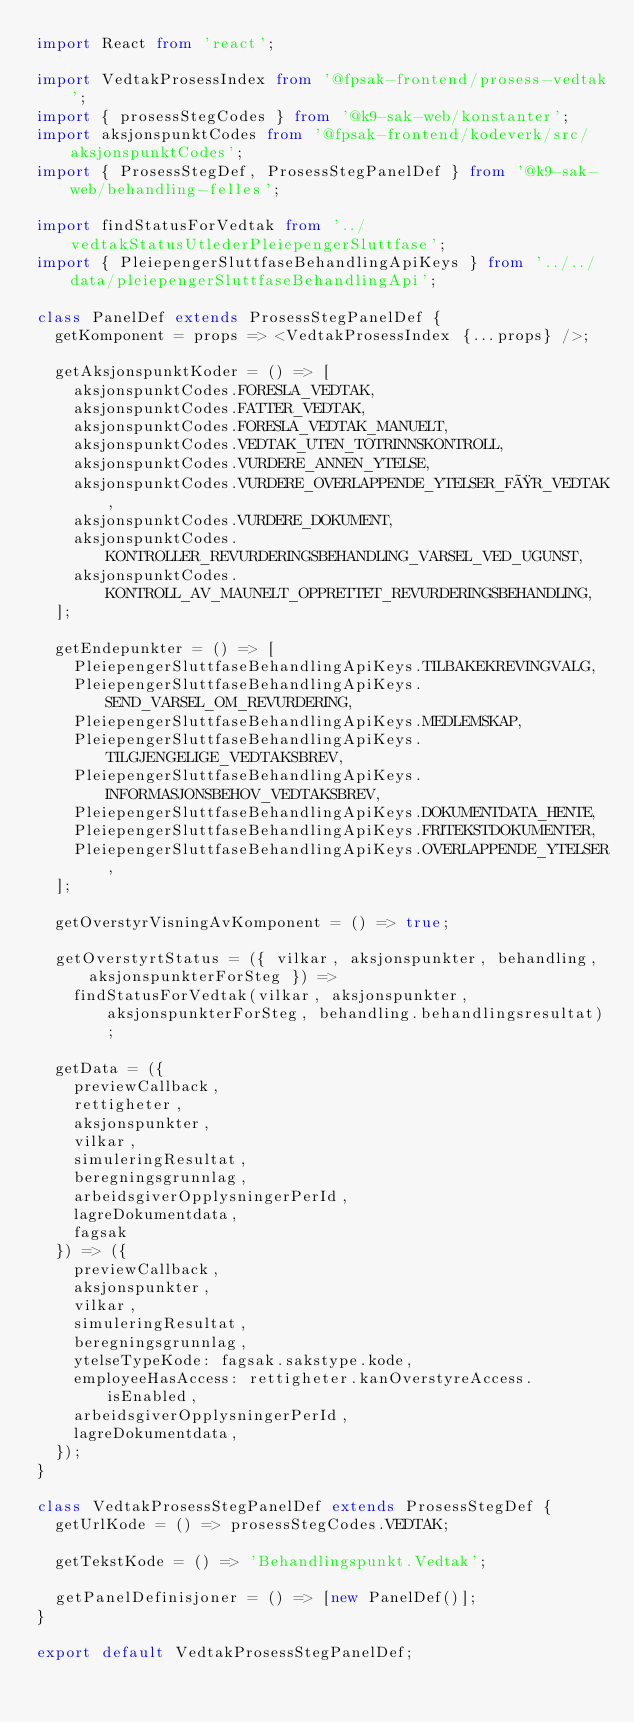<code> <loc_0><loc_0><loc_500><loc_500><_TypeScript_>import React from 'react';

import VedtakProsessIndex from '@fpsak-frontend/prosess-vedtak';
import { prosessStegCodes } from '@k9-sak-web/konstanter';
import aksjonspunktCodes from '@fpsak-frontend/kodeverk/src/aksjonspunktCodes';
import { ProsessStegDef, ProsessStegPanelDef } from '@k9-sak-web/behandling-felles';

import findStatusForVedtak from '../vedtakStatusUtlederPleiepengerSluttfase';
import { PleiepengerSluttfaseBehandlingApiKeys } from '../../data/pleiepengerSluttfaseBehandlingApi';

class PanelDef extends ProsessStegPanelDef {
  getKomponent = props => <VedtakProsessIndex {...props} />;

  getAksjonspunktKoder = () => [
    aksjonspunktCodes.FORESLA_VEDTAK,
    aksjonspunktCodes.FATTER_VEDTAK,
    aksjonspunktCodes.FORESLA_VEDTAK_MANUELT,
    aksjonspunktCodes.VEDTAK_UTEN_TOTRINNSKONTROLL,
    aksjonspunktCodes.VURDERE_ANNEN_YTELSE,
    aksjonspunktCodes.VURDERE_OVERLAPPENDE_YTELSER_FØR_VEDTAK,
    aksjonspunktCodes.VURDERE_DOKUMENT,
    aksjonspunktCodes.KONTROLLER_REVURDERINGSBEHANDLING_VARSEL_VED_UGUNST,
    aksjonspunktCodes.KONTROLL_AV_MAUNELT_OPPRETTET_REVURDERINGSBEHANDLING,
  ];

  getEndepunkter = () => [
    PleiepengerSluttfaseBehandlingApiKeys.TILBAKEKREVINGVALG,
    PleiepengerSluttfaseBehandlingApiKeys.SEND_VARSEL_OM_REVURDERING,
    PleiepengerSluttfaseBehandlingApiKeys.MEDLEMSKAP,
    PleiepengerSluttfaseBehandlingApiKeys.TILGJENGELIGE_VEDTAKSBREV,
    PleiepengerSluttfaseBehandlingApiKeys.INFORMASJONSBEHOV_VEDTAKSBREV,
    PleiepengerSluttfaseBehandlingApiKeys.DOKUMENTDATA_HENTE,
    PleiepengerSluttfaseBehandlingApiKeys.FRITEKSTDOKUMENTER,
    PleiepengerSluttfaseBehandlingApiKeys.OVERLAPPENDE_YTELSER,
  ];

  getOverstyrVisningAvKomponent = () => true;

  getOverstyrtStatus = ({ vilkar, aksjonspunkter, behandling, aksjonspunkterForSteg }) =>
    findStatusForVedtak(vilkar, aksjonspunkter, aksjonspunkterForSteg, behandling.behandlingsresultat);

  getData = ({
    previewCallback,
    rettigheter,
    aksjonspunkter,
    vilkar,
    simuleringResultat,
    beregningsgrunnlag,
    arbeidsgiverOpplysningerPerId,
    lagreDokumentdata,
    fagsak
  }) => ({
    previewCallback,
    aksjonspunkter,
    vilkar,
    simuleringResultat,
    beregningsgrunnlag,
    ytelseTypeKode: fagsak.sakstype.kode,
    employeeHasAccess: rettigheter.kanOverstyreAccess.isEnabled,
    arbeidsgiverOpplysningerPerId,
    lagreDokumentdata,
  });
}

class VedtakProsessStegPanelDef extends ProsessStegDef {
  getUrlKode = () => prosessStegCodes.VEDTAK;

  getTekstKode = () => 'Behandlingspunkt.Vedtak';

  getPanelDefinisjoner = () => [new PanelDef()];
}

export default VedtakProsessStegPanelDef;
</code> 